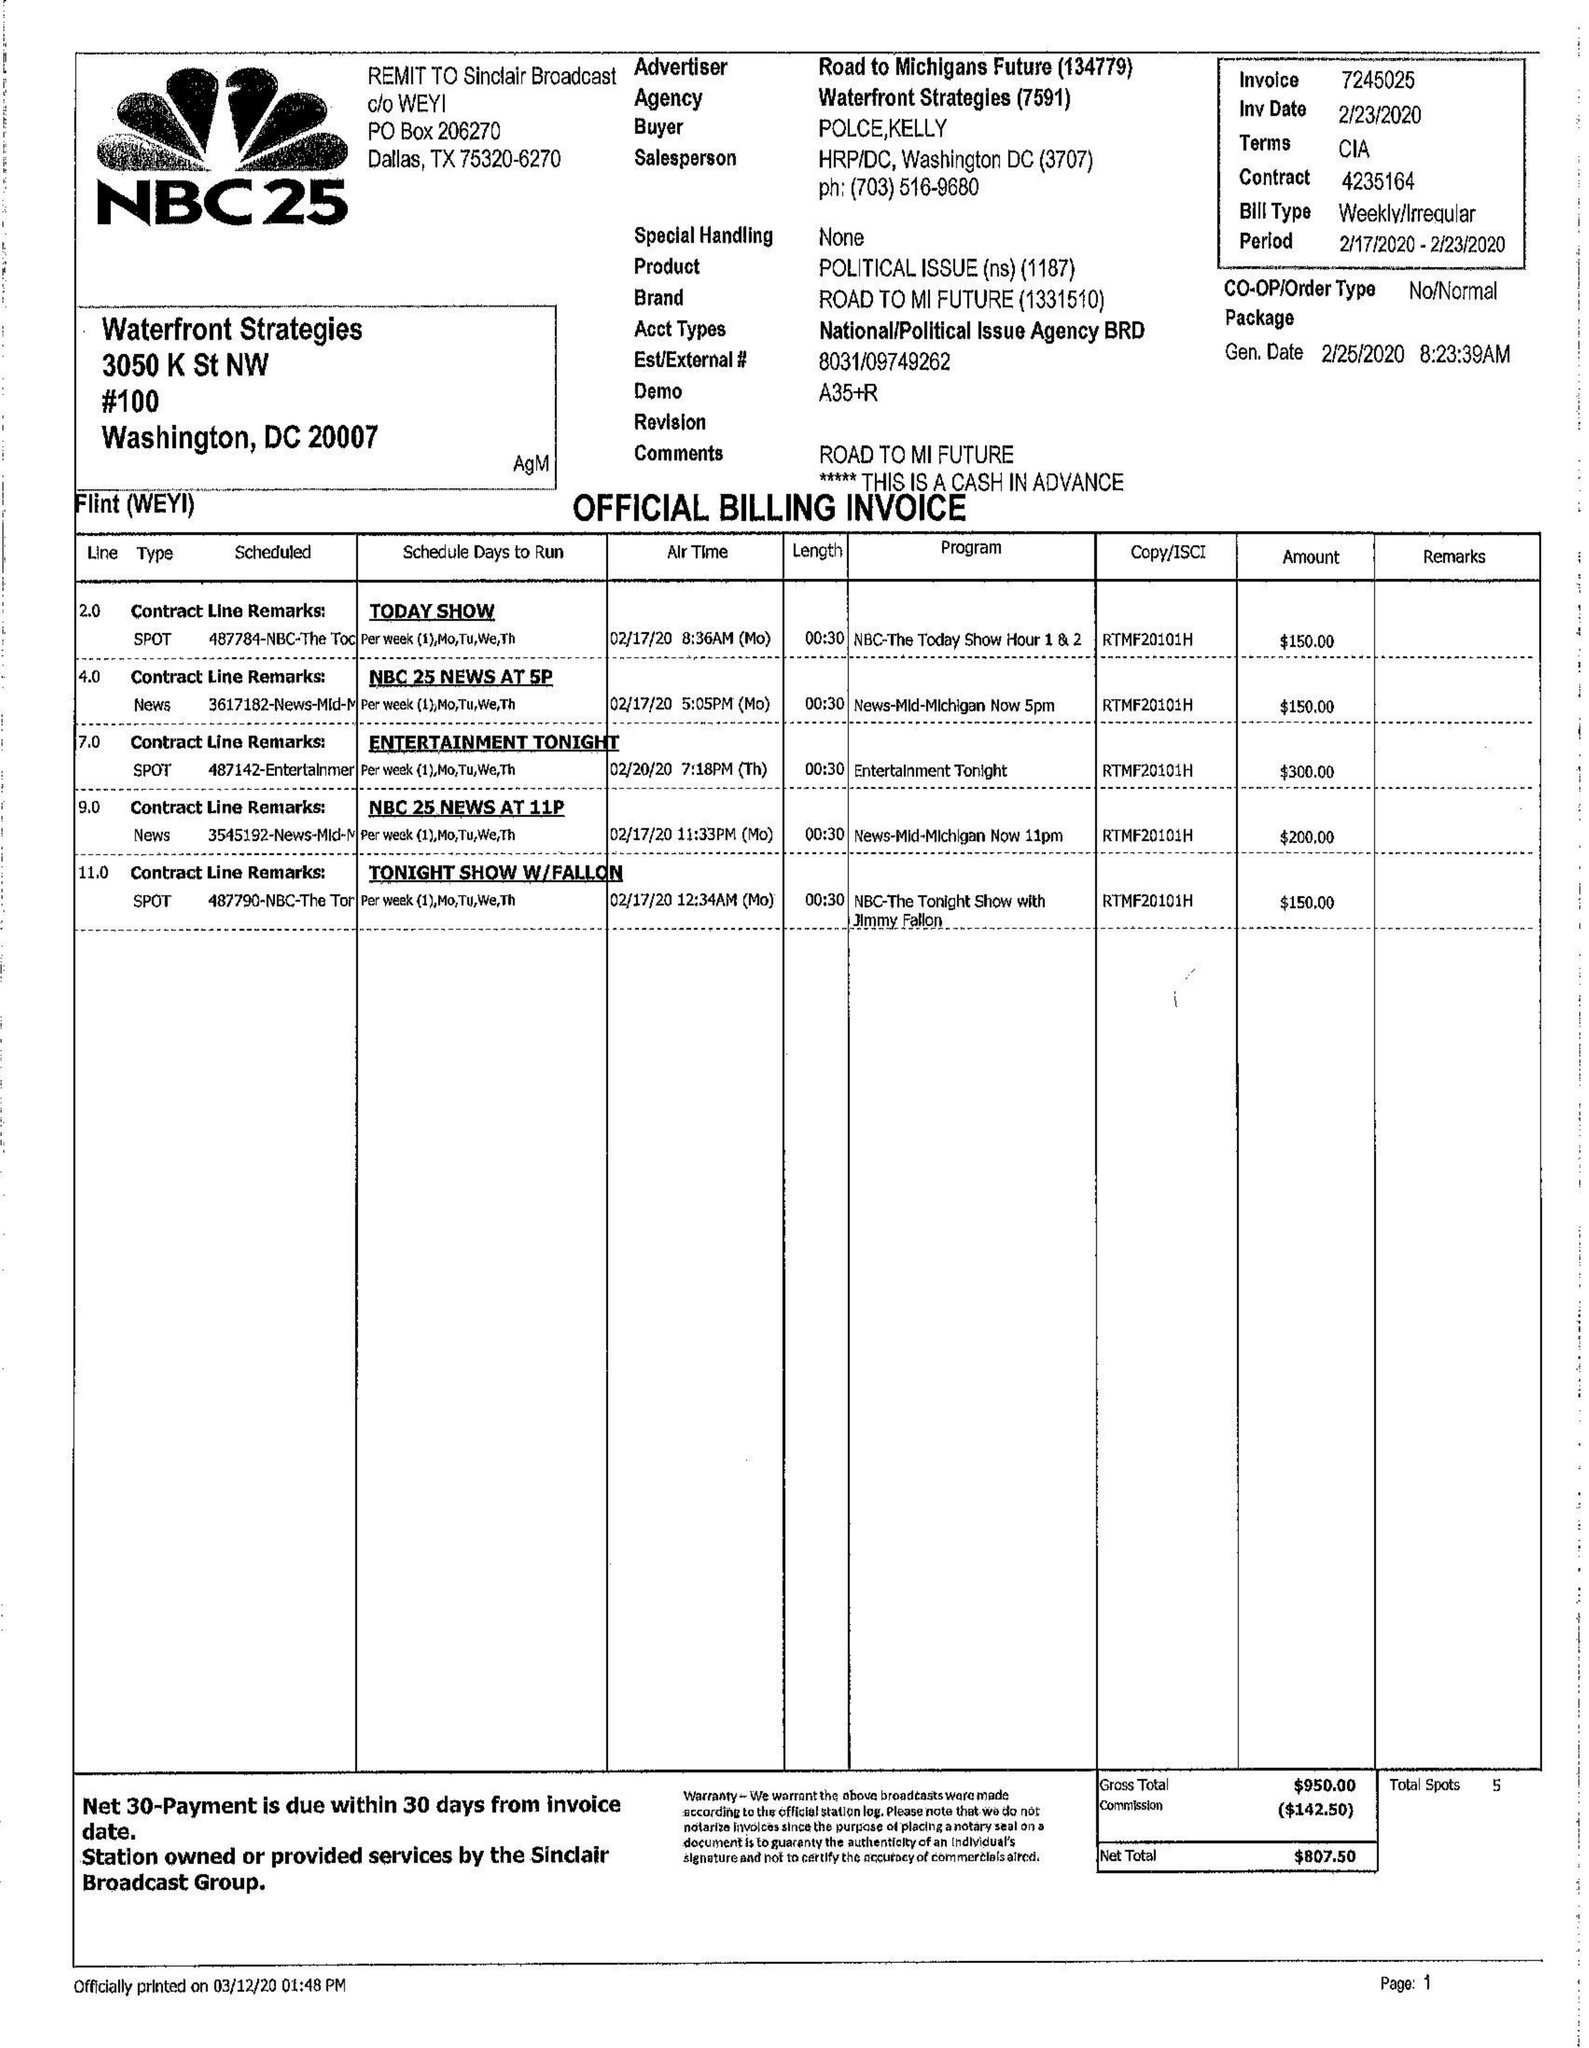What is the value for the advertiser?
Answer the question using a single word or phrase. ROAD TO MICHIGANS FUTURE 